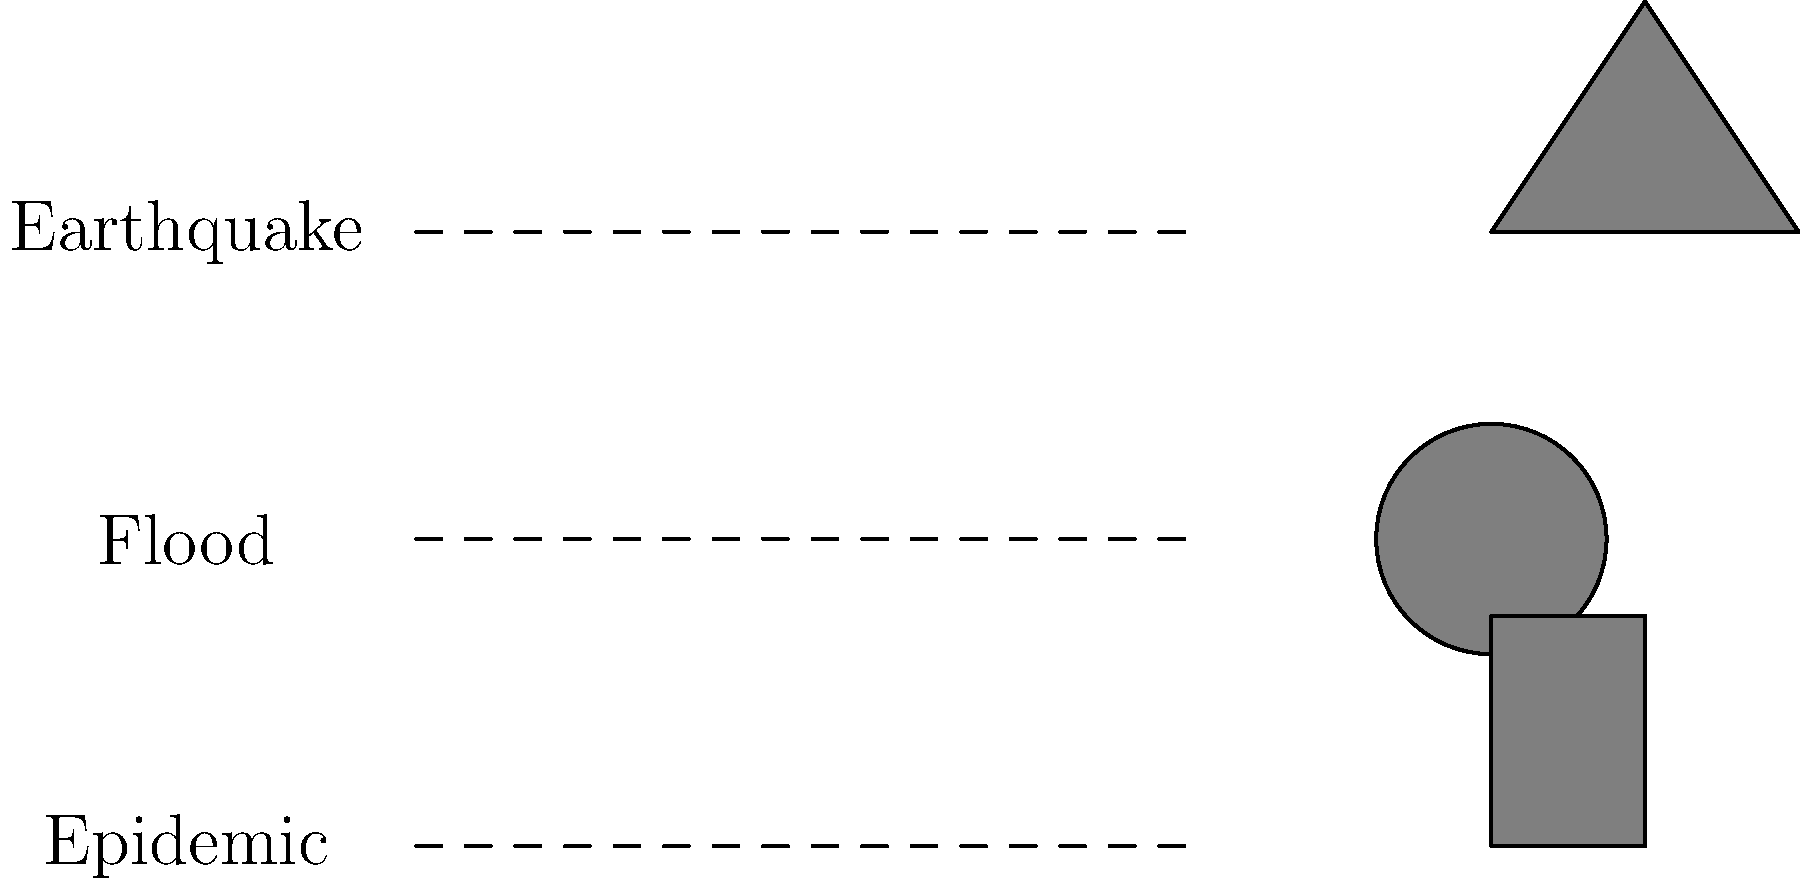Match the appropriate relief supplies to each disaster type by connecting the disaster to its most crucial immediate supply need. To match the appropriate relief supplies to each disaster type, we need to consider the immediate needs of affected populations in each scenario:

1. Earthquake:
   - Primary concern: Shelter
   - Explanation: Earthquakes often destroy buildings, leaving people without homes.
   - Matching icon: Tent

2. Flood:
   - Primary concern: Clean water
   - Explanation: Floods contaminate water sources, making safe drinking water crucial.
   - Matching icon: Water drop

3. Epidemic:
   - Primary concern: Medical supplies
   - Explanation: During disease outbreaks, medicines and medical equipment are essential.
   - Matching icon: Medicine bottle

While all these supplies are important in most disaster scenarios, the question asks for the most crucial immediate need for each disaster type. The correct matches focus on addressing the most urgent and specific concerns for each disaster type in the immediate aftermath.
Answer: Earthquake-Tent, Flood-Water, Epidemic-Medicine 